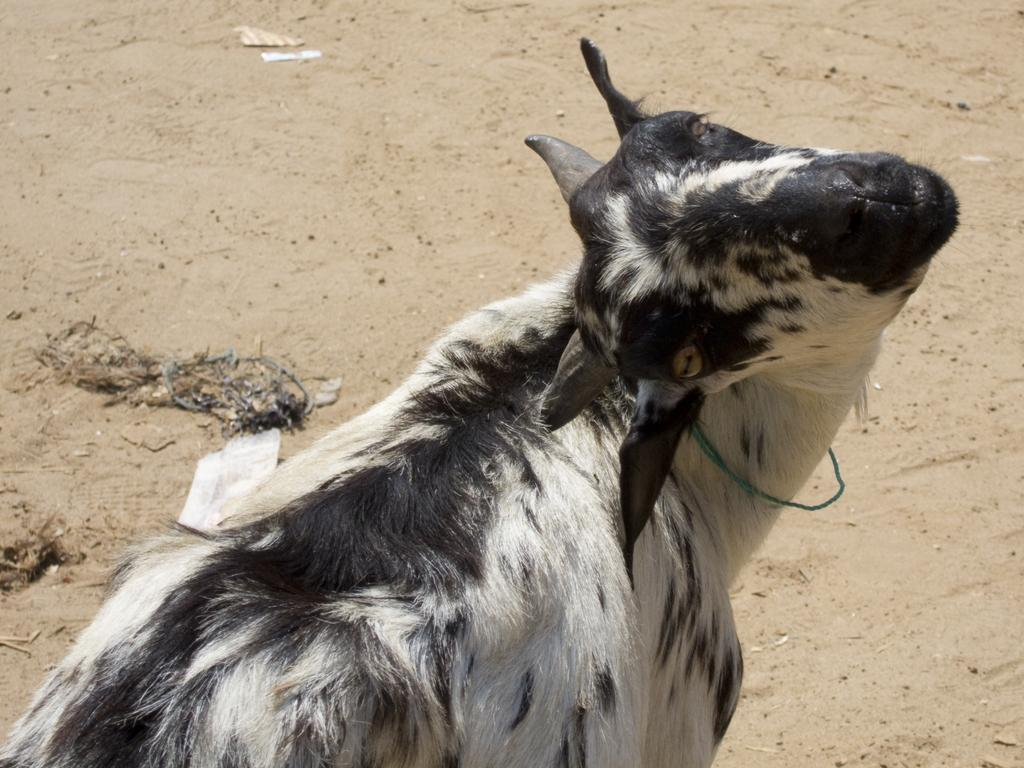What is the main subject in the middle of the image? There is a goat in the middle of the image. Can you describe the appearance of the goat? The goat has black and white color. What can be seen in the background of the image? In the background, there is sand on the ground. Reasoning: Let' Let's think step by step in order to produce the conversation. We start by identifying the main subject of the image, which is the goat. Then, we describe the appearance of the goat, focusing on its color. Finally, we mention the background of the image, which includes sand on the ground. Each question is designed to elicit a specific detail about the image that is known from the provided facts. Absurd Question/Answer: What time of day is it in the image, and how much sugar is present in the goat's diet? The time of day is not mentioned in the image, and there is no information about the goat's diet or sugar intake. What time of day is it in the image, and how much sugar is present in the goat's diet? The time of day is not mentioned in the image, and there is no information about the goat's diet or sugar intake. 